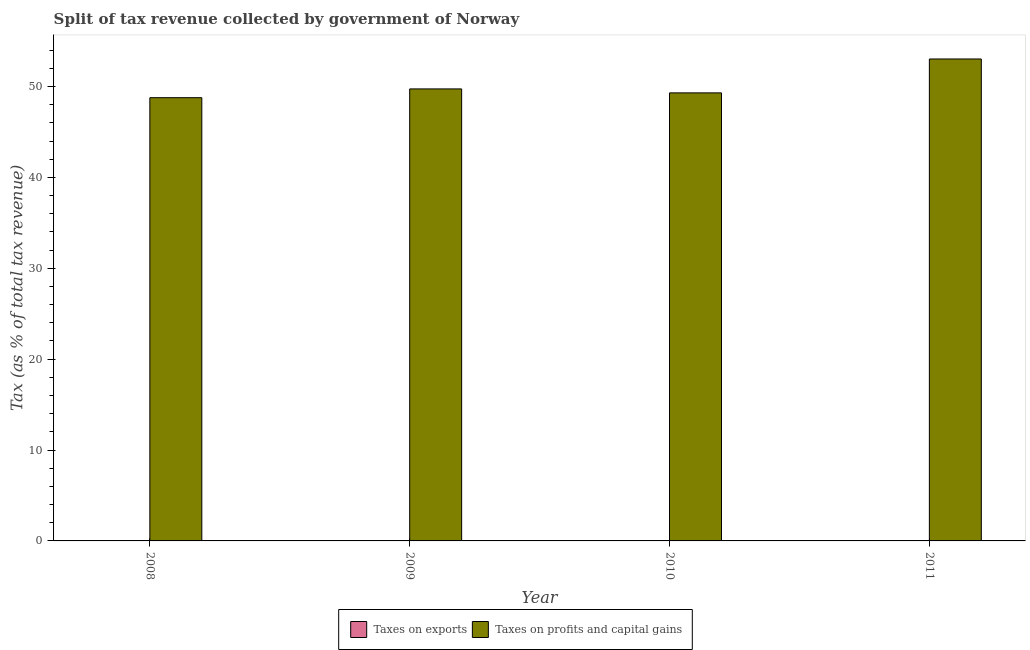How many groups of bars are there?
Your answer should be very brief. 4. Are the number of bars per tick equal to the number of legend labels?
Your answer should be very brief. Yes. How many bars are there on the 1st tick from the left?
Make the answer very short. 2. What is the percentage of revenue obtained from taxes on profits and capital gains in 2009?
Provide a succinct answer. 49.73. Across all years, what is the maximum percentage of revenue obtained from taxes on profits and capital gains?
Ensure brevity in your answer.  53.03. Across all years, what is the minimum percentage of revenue obtained from taxes on profits and capital gains?
Give a very brief answer. 48.76. In which year was the percentage of revenue obtained from taxes on exports maximum?
Provide a succinct answer. 2011. What is the total percentage of revenue obtained from taxes on exports in the graph?
Ensure brevity in your answer.  0.08. What is the difference between the percentage of revenue obtained from taxes on profits and capital gains in 2009 and that in 2011?
Keep it short and to the point. -3.3. What is the difference between the percentage of revenue obtained from taxes on exports in 2011 and the percentage of revenue obtained from taxes on profits and capital gains in 2010?
Your answer should be very brief. 0. What is the average percentage of revenue obtained from taxes on exports per year?
Your answer should be very brief. 0.02. What is the ratio of the percentage of revenue obtained from taxes on exports in 2008 to that in 2010?
Your response must be concise. 0.77. Is the difference between the percentage of revenue obtained from taxes on profits and capital gains in 2008 and 2011 greater than the difference between the percentage of revenue obtained from taxes on exports in 2008 and 2011?
Your answer should be compact. No. What is the difference between the highest and the second highest percentage of revenue obtained from taxes on profits and capital gains?
Provide a succinct answer. 3.3. What is the difference between the highest and the lowest percentage of revenue obtained from taxes on exports?
Make the answer very short. 0.01. In how many years, is the percentage of revenue obtained from taxes on profits and capital gains greater than the average percentage of revenue obtained from taxes on profits and capital gains taken over all years?
Ensure brevity in your answer.  1. Is the sum of the percentage of revenue obtained from taxes on profits and capital gains in 2008 and 2011 greater than the maximum percentage of revenue obtained from taxes on exports across all years?
Provide a succinct answer. Yes. What does the 1st bar from the left in 2009 represents?
Your response must be concise. Taxes on exports. What does the 2nd bar from the right in 2011 represents?
Your answer should be compact. Taxes on exports. How many bars are there?
Keep it short and to the point. 8. Are all the bars in the graph horizontal?
Your answer should be very brief. No. What is the difference between two consecutive major ticks on the Y-axis?
Offer a very short reply. 10. Does the graph contain any zero values?
Make the answer very short. No. How many legend labels are there?
Your answer should be very brief. 2. What is the title of the graph?
Provide a short and direct response. Split of tax revenue collected by government of Norway. Does "Automatic Teller Machines" appear as one of the legend labels in the graph?
Provide a short and direct response. No. What is the label or title of the X-axis?
Give a very brief answer. Year. What is the label or title of the Y-axis?
Ensure brevity in your answer.  Tax (as % of total tax revenue). What is the Tax (as % of total tax revenue) of Taxes on exports in 2008?
Ensure brevity in your answer.  0.02. What is the Tax (as % of total tax revenue) in Taxes on profits and capital gains in 2008?
Your answer should be very brief. 48.76. What is the Tax (as % of total tax revenue) of Taxes on exports in 2009?
Offer a very short reply. 0.02. What is the Tax (as % of total tax revenue) in Taxes on profits and capital gains in 2009?
Keep it short and to the point. 49.73. What is the Tax (as % of total tax revenue) of Taxes on exports in 2010?
Provide a succinct answer. 0.02. What is the Tax (as % of total tax revenue) in Taxes on profits and capital gains in 2010?
Keep it short and to the point. 49.3. What is the Tax (as % of total tax revenue) of Taxes on exports in 2011?
Your answer should be very brief. 0.02. What is the Tax (as % of total tax revenue) in Taxes on profits and capital gains in 2011?
Ensure brevity in your answer.  53.03. Across all years, what is the maximum Tax (as % of total tax revenue) of Taxes on exports?
Ensure brevity in your answer.  0.02. Across all years, what is the maximum Tax (as % of total tax revenue) of Taxes on profits and capital gains?
Offer a terse response. 53.03. Across all years, what is the minimum Tax (as % of total tax revenue) in Taxes on exports?
Your answer should be very brief. 0.02. Across all years, what is the minimum Tax (as % of total tax revenue) in Taxes on profits and capital gains?
Keep it short and to the point. 48.76. What is the total Tax (as % of total tax revenue) in Taxes on exports in the graph?
Ensure brevity in your answer.  0.08. What is the total Tax (as % of total tax revenue) of Taxes on profits and capital gains in the graph?
Keep it short and to the point. 200.82. What is the difference between the Tax (as % of total tax revenue) of Taxes on exports in 2008 and that in 2009?
Keep it short and to the point. -0. What is the difference between the Tax (as % of total tax revenue) of Taxes on profits and capital gains in 2008 and that in 2009?
Keep it short and to the point. -0.97. What is the difference between the Tax (as % of total tax revenue) in Taxes on exports in 2008 and that in 2010?
Provide a succinct answer. -0.01. What is the difference between the Tax (as % of total tax revenue) of Taxes on profits and capital gains in 2008 and that in 2010?
Your answer should be very brief. -0.53. What is the difference between the Tax (as % of total tax revenue) in Taxes on exports in 2008 and that in 2011?
Ensure brevity in your answer.  -0.01. What is the difference between the Tax (as % of total tax revenue) of Taxes on profits and capital gains in 2008 and that in 2011?
Your response must be concise. -4.26. What is the difference between the Tax (as % of total tax revenue) of Taxes on exports in 2009 and that in 2010?
Offer a terse response. -0. What is the difference between the Tax (as % of total tax revenue) in Taxes on profits and capital gains in 2009 and that in 2010?
Offer a very short reply. 0.44. What is the difference between the Tax (as % of total tax revenue) in Taxes on exports in 2009 and that in 2011?
Offer a very short reply. -0. What is the difference between the Tax (as % of total tax revenue) in Taxes on profits and capital gains in 2009 and that in 2011?
Offer a terse response. -3.3. What is the difference between the Tax (as % of total tax revenue) in Taxes on exports in 2010 and that in 2011?
Give a very brief answer. -0. What is the difference between the Tax (as % of total tax revenue) in Taxes on profits and capital gains in 2010 and that in 2011?
Keep it short and to the point. -3.73. What is the difference between the Tax (as % of total tax revenue) of Taxes on exports in 2008 and the Tax (as % of total tax revenue) of Taxes on profits and capital gains in 2009?
Offer a terse response. -49.71. What is the difference between the Tax (as % of total tax revenue) of Taxes on exports in 2008 and the Tax (as % of total tax revenue) of Taxes on profits and capital gains in 2010?
Your answer should be very brief. -49.28. What is the difference between the Tax (as % of total tax revenue) of Taxes on exports in 2008 and the Tax (as % of total tax revenue) of Taxes on profits and capital gains in 2011?
Your answer should be compact. -53.01. What is the difference between the Tax (as % of total tax revenue) of Taxes on exports in 2009 and the Tax (as % of total tax revenue) of Taxes on profits and capital gains in 2010?
Keep it short and to the point. -49.27. What is the difference between the Tax (as % of total tax revenue) in Taxes on exports in 2009 and the Tax (as % of total tax revenue) in Taxes on profits and capital gains in 2011?
Provide a short and direct response. -53.01. What is the difference between the Tax (as % of total tax revenue) of Taxes on exports in 2010 and the Tax (as % of total tax revenue) of Taxes on profits and capital gains in 2011?
Your answer should be compact. -53. What is the average Tax (as % of total tax revenue) in Taxes on exports per year?
Offer a very short reply. 0.02. What is the average Tax (as % of total tax revenue) in Taxes on profits and capital gains per year?
Give a very brief answer. 50.2. In the year 2008, what is the difference between the Tax (as % of total tax revenue) in Taxes on exports and Tax (as % of total tax revenue) in Taxes on profits and capital gains?
Provide a succinct answer. -48.75. In the year 2009, what is the difference between the Tax (as % of total tax revenue) of Taxes on exports and Tax (as % of total tax revenue) of Taxes on profits and capital gains?
Your answer should be compact. -49.71. In the year 2010, what is the difference between the Tax (as % of total tax revenue) in Taxes on exports and Tax (as % of total tax revenue) in Taxes on profits and capital gains?
Keep it short and to the point. -49.27. In the year 2011, what is the difference between the Tax (as % of total tax revenue) of Taxes on exports and Tax (as % of total tax revenue) of Taxes on profits and capital gains?
Keep it short and to the point. -53. What is the ratio of the Tax (as % of total tax revenue) of Taxes on exports in 2008 to that in 2009?
Ensure brevity in your answer.  0.8. What is the ratio of the Tax (as % of total tax revenue) in Taxes on profits and capital gains in 2008 to that in 2009?
Give a very brief answer. 0.98. What is the ratio of the Tax (as % of total tax revenue) of Taxes on exports in 2008 to that in 2010?
Your response must be concise. 0.77. What is the ratio of the Tax (as % of total tax revenue) of Taxes on profits and capital gains in 2008 to that in 2010?
Your answer should be very brief. 0.99. What is the ratio of the Tax (as % of total tax revenue) in Taxes on exports in 2008 to that in 2011?
Your response must be concise. 0.75. What is the ratio of the Tax (as % of total tax revenue) in Taxes on profits and capital gains in 2008 to that in 2011?
Make the answer very short. 0.92. What is the ratio of the Tax (as % of total tax revenue) of Taxes on exports in 2009 to that in 2010?
Keep it short and to the point. 0.96. What is the ratio of the Tax (as % of total tax revenue) in Taxes on profits and capital gains in 2009 to that in 2010?
Keep it short and to the point. 1.01. What is the ratio of the Tax (as % of total tax revenue) in Taxes on exports in 2009 to that in 2011?
Give a very brief answer. 0.93. What is the ratio of the Tax (as % of total tax revenue) of Taxes on profits and capital gains in 2009 to that in 2011?
Keep it short and to the point. 0.94. What is the ratio of the Tax (as % of total tax revenue) of Taxes on exports in 2010 to that in 2011?
Provide a short and direct response. 0.97. What is the ratio of the Tax (as % of total tax revenue) of Taxes on profits and capital gains in 2010 to that in 2011?
Provide a short and direct response. 0.93. What is the difference between the highest and the second highest Tax (as % of total tax revenue) of Taxes on exports?
Ensure brevity in your answer.  0. What is the difference between the highest and the second highest Tax (as % of total tax revenue) of Taxes on profits and capital gains?
Your answer should be compact. 3.3. What is the difference between the highest and the lowest Tax (as % of total tax revenue) in Taxes on exports?
Keep it short and to the point. 0.01. What is the difference between the highest and the lowest Tax (as % of total tax revenue) in Taxes on profits and capital gains?
Ensure brevity in your answer.  4.26. 